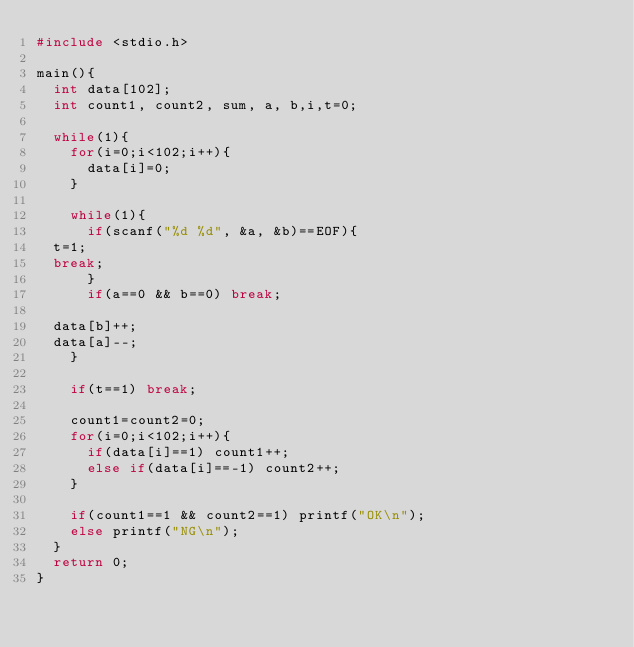Convert code to text. <code><loc_0><loc_0><loc_500><loc_500><_C_>#include <stdio.h>

main(){
  int data[102];
  int count1, count2, sum, a, b,i,t=0;

  while(1){
    for(i=0;i<102;i++){
      data[i]=0;
    }
    
    while(1){
      if(scanf("%d %d", &a, &b)==EOF){
	t=1;
	break;
      }
      if(a==0 && b==0) break;

	data[b]++;
	data[a]--;
    }

    if(t==1) break;

    count1=count2=0;
    for(i=0;i<102;i++){
      if(data[i]==1) count1++;
      else if(data[i]==-1) count2++;
    }

    if(count1==1 && count2==1) printf("OK\n");
    else printf("NG\n");
  }
  return 0;
}</code> 